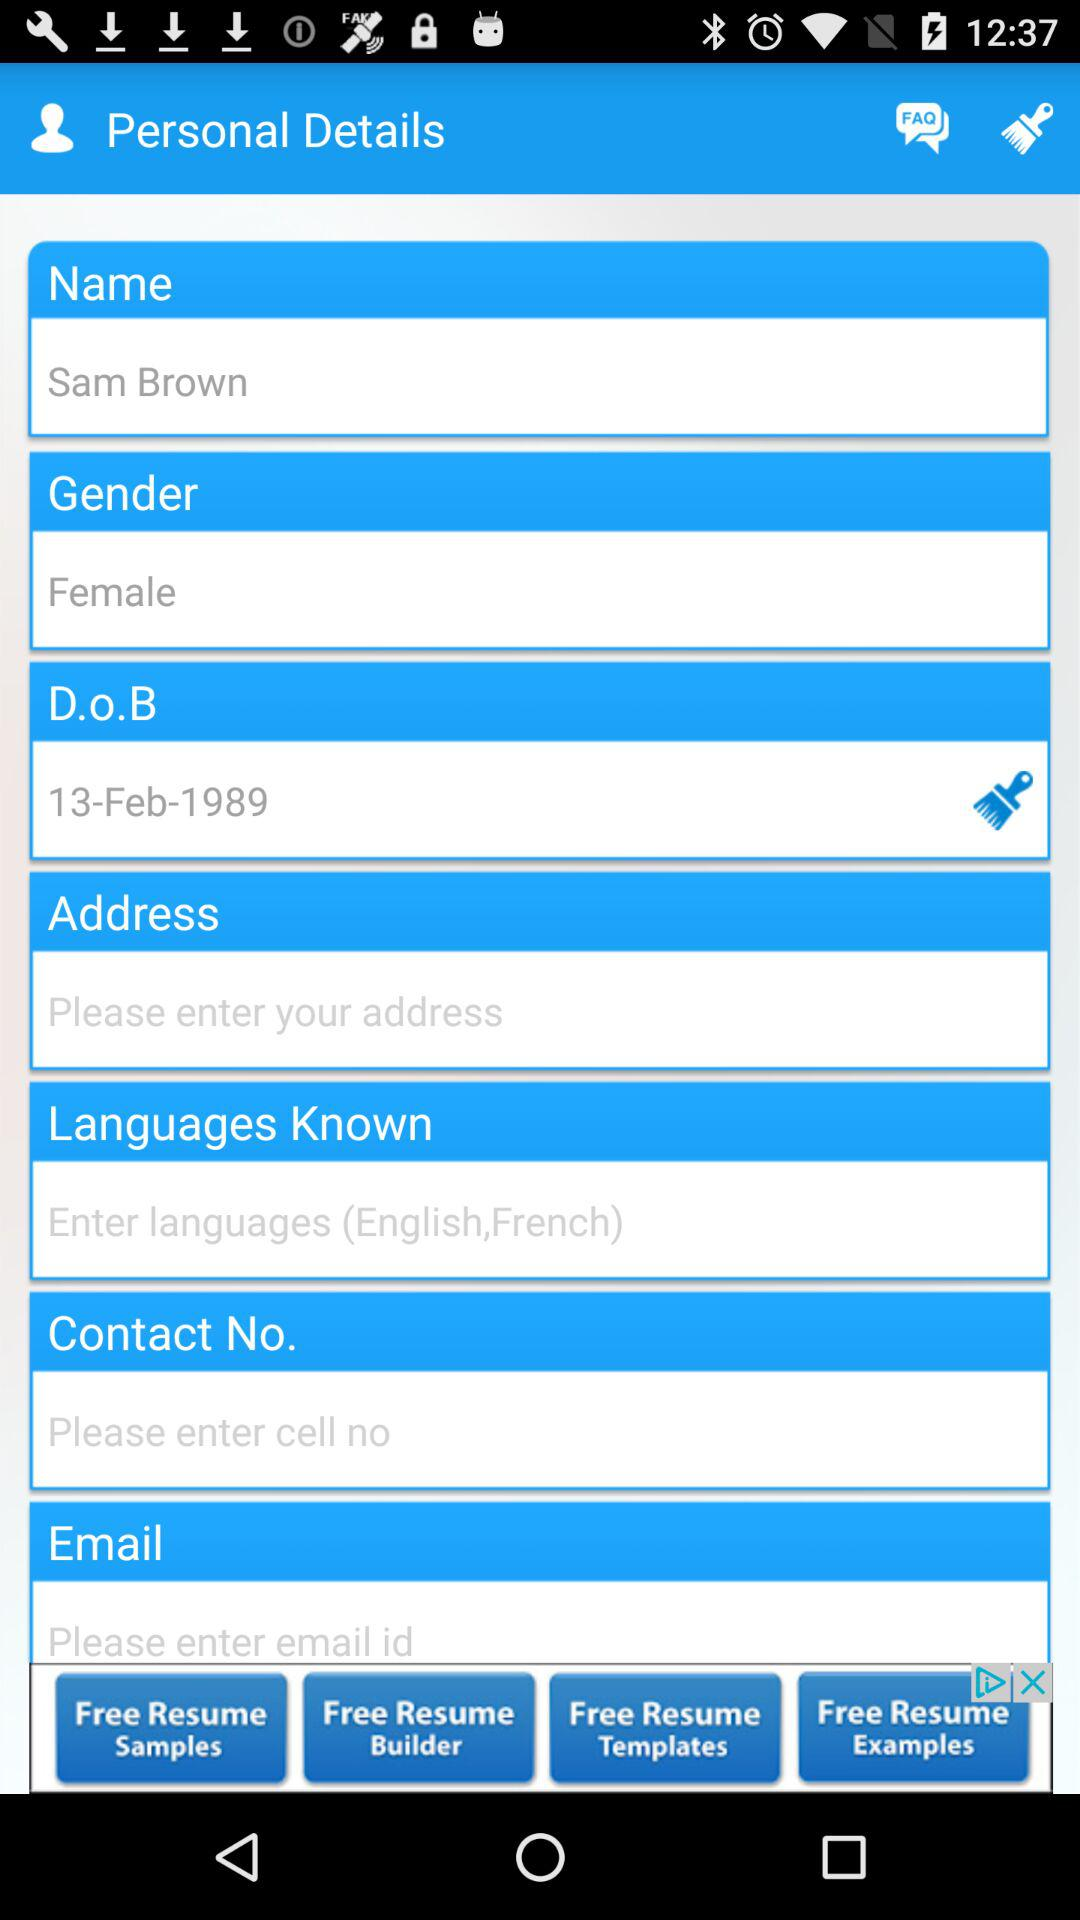What is the date of birth? The date of birth is February 13, 1989. 